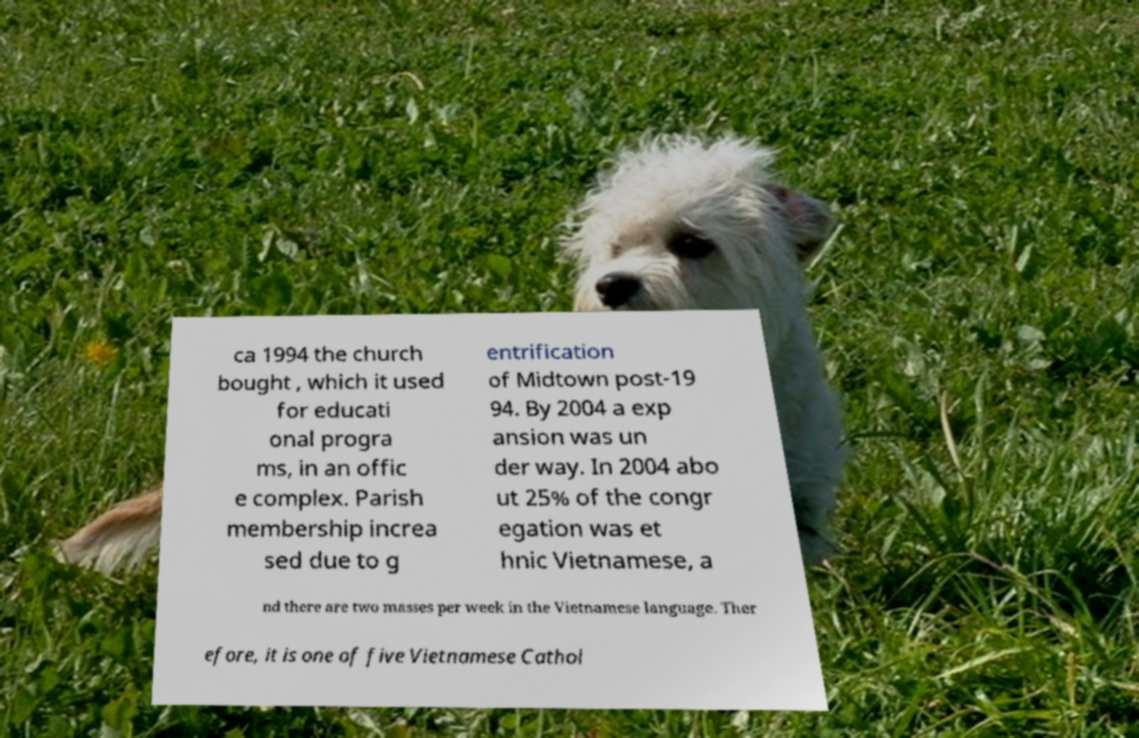Could you extract and type out the text from this image? ca 1994 the church bought , which it used for educati onal progra ms, in an offic e complex. Parish membership increa sed due to g entrification of Midtown post-19 94. By 2004 a exp ansion was un der way. In 2004 abo ut 25% of the congr egation was et hnic Vietnamese, a nd there are two masses per week in the Vietnamese language. Ther efore, it is one of five Vietnamese Cathol 